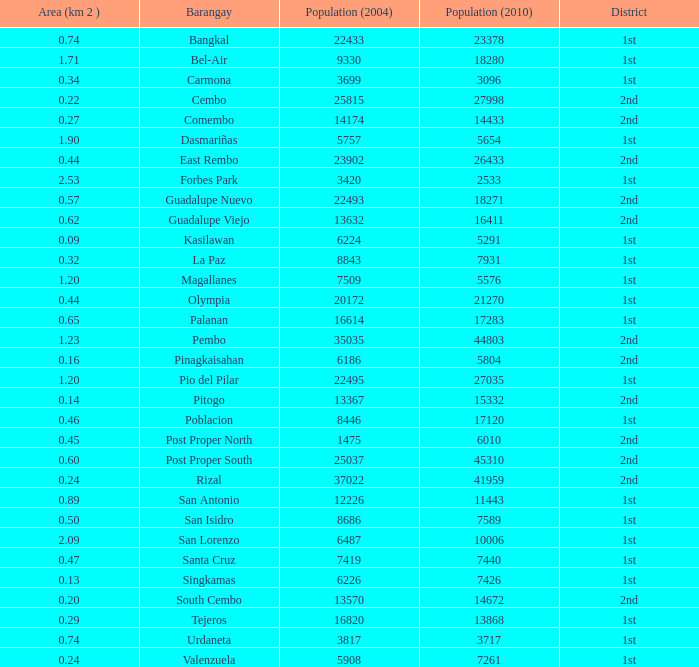What is the area where barangay is guadalupe viejo? 0.62. 